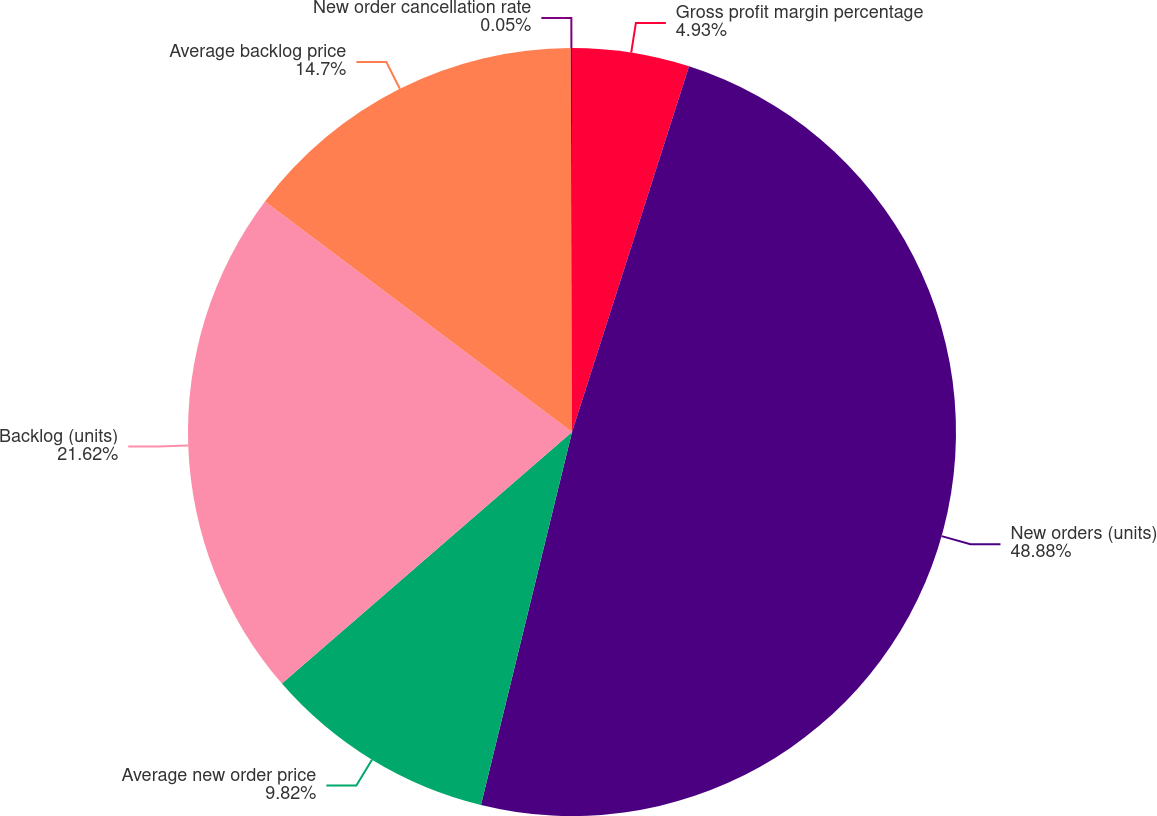<chart> <loc_0><loc_0><loc_500><loc_500><pie_chart><fcel>Gross profit margin percentage<fcel>New orders (units)<fcel>Average new order price<fcel>Backlog (units)<fcel>Average backlog price<fcel>New order cancellation rate<nl><fcel>4.93%<fcel>48.88%<fcel>9.82%<fcel>21.62%<fcel>14.7%<fcel>0.05%<nl></chart> 